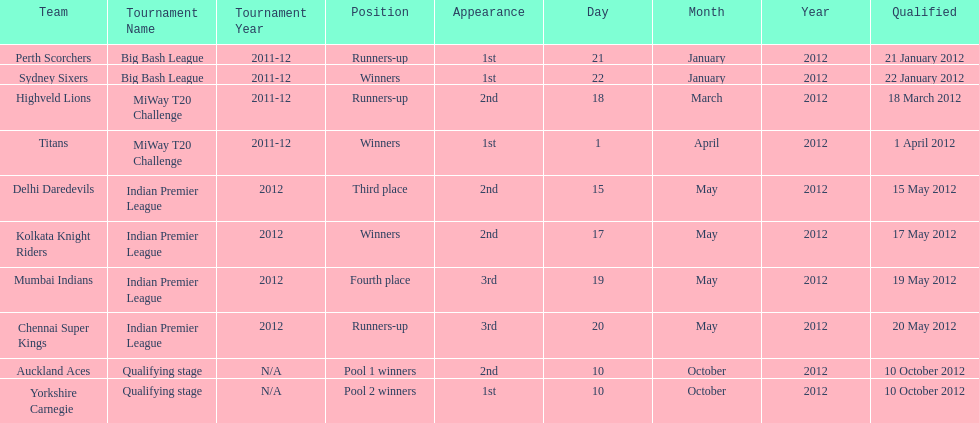Which teams were the last to qualify? Auckland Aces, Yorkshire Carnegie. 